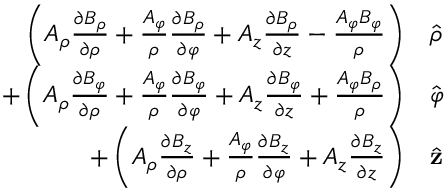Convert formula to latex. <formula><loc_0><loc_0><loc_500><loc_500>\begin{array} { r l } { \left ( A _ { \rho } { \frac { \partial B _ { \rho } } { \partial \rho } } + { \frac { A _ { \varphi } } { \rho } } { \frac { \partial B _ { \rho } } { \partial \varphi } } + A _ { z } { \frac { \partial B _ { \rho } } { \partial z } } - { \frac { A _ { \varphi } B _ { \varphi } } { \rho } } \right ) } & { \hat { \rho } } } \\ { + \left ( A _ { \rho } { \frac { \partial B _ { \varphi } } { \partial \rho } } + { \frac { A _ { \varphi } } { \rho } } { \frac { \partial B _ { \varphi } } { \partial \varphi } } + A _ { z } { \frac { \partial B _ { \varphi } } { \partial z } } + { \frac { A _ { \varphi } B _ { \rho } } { \rho } } \right ) } & { \hat { \varphi } } } \\ { + \left ( A _ { \rho } { \frac { \partial B _ { z } } { \partial \rho } } + { \frac { A _ { \varphi } } { \rho } } { \frac { \partial B _ { z } } { \partial \varphi } } + A _ { z } { \frac { \partial B _ { z } } { \partial z } } \right ) } & { \hat { z } } } \end{array}</formula> 